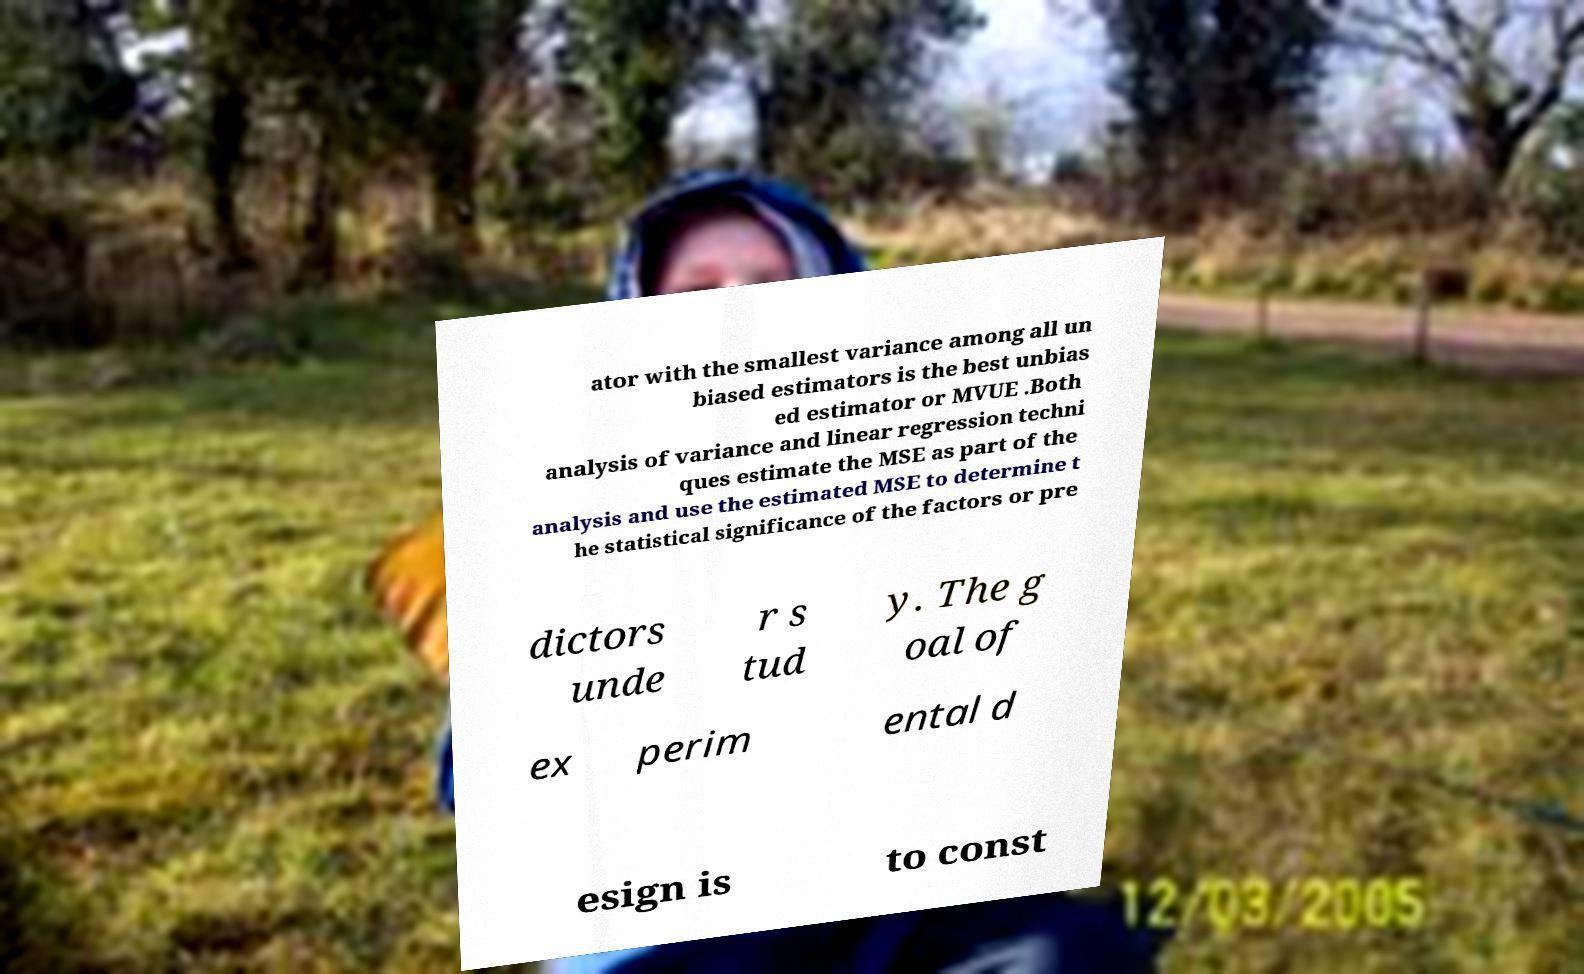Can you accurately transcribe the text from the provided image for me? ator with the smallest variance among all un biased estimators is the best unbias ed estimator or MVUE .Both analysis of variance and linear regression techni ques estimate the MSE as part of the analysis and use the estimated MSE to determine t he statistical significance of the factors or pre dictors unde r s tud y. The g oal of ex perim ental d esign is to const 